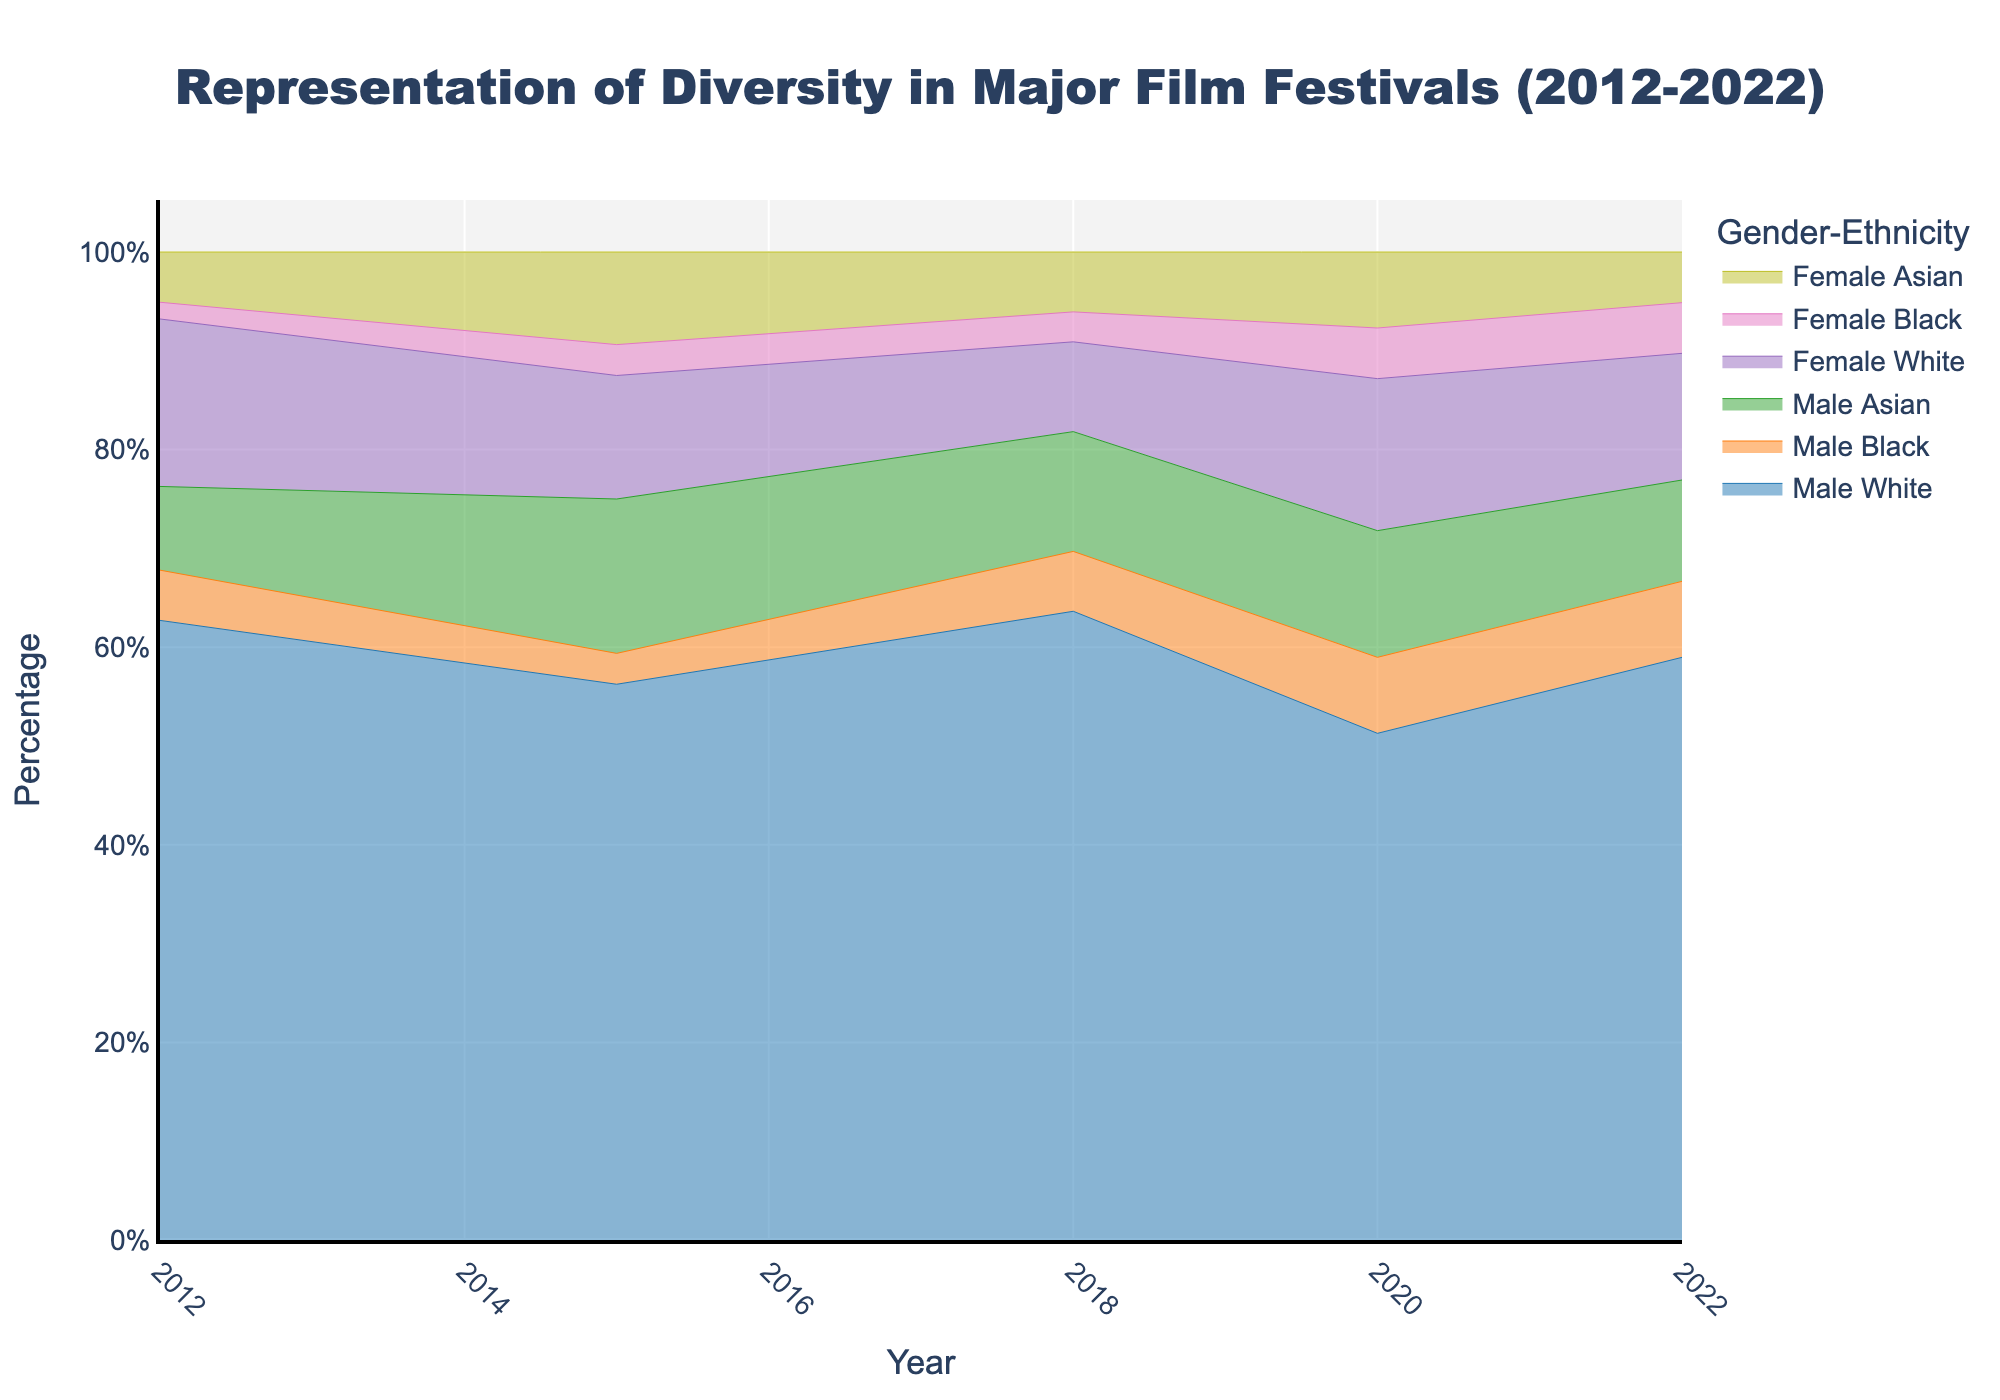What's the title of the figure? The title is usually prominently displayed at the top of the figure. Here, the title of the figure is given as "Representation of Diversity in Major Film Festivals (2012-2022)."
Answer: Representation of Diversity in Major Film Festivals (2012-2022) Which axis represents the year? In most graphs, the x-axis typically represents time when it's involved. In this figure, the x-axis displays the years from 2012 to 2022.
Answer: x-axis What color is used to represent male white directors? The figure uses different colors to represent different categories. The line representing male white directors is colored in blue.
Answer: Blue How does the percentage of male white directors change from 2012 to 2022? To find out how the percentage changes, look at the blue line representing male white directors. Notice the trend from 2012 to 2022. The percentage starts relatively high in 2012, fluctuates over the years but remains one of the higher percentages throughout the period, ending similarly high in 2022.
Answer: High at start and remains high What is the overall trend in the representation of female black directors from 2012 to 2022? Observe the line for female black directors, indicated by a specific color. From 2012 to 2022, the percentage shows a slight increase over time, indicating a gradual improvement in their representation in major film festivals.
Answer: Gradual increase Which ethnic group of male directors shows the most significant growth over the decade? Compare the lines for male directors of different ethnicities (white, black, Asian). The group with the steepest upward trajectory indicates the most growth. Male Asian directors show a noticeable increase over the decade.
Answer: Male Asian directors How do male and female white directors' representations compare in 2018? Look at the specific points in 2018 for both the blue (male white) and purple (female white) lines. Compare their percentages directly at the year 2018. Male white directors have a higher representation compared to female white directors in 2018.
Answer: Male higher than female What year shows the highest percentage of female Asian directors? To find this, trace the line representing female Asian directors (yellow). Identify the year where the line reaches its peak to find the highest percentage year.
Answer: 2015 How does the combined representation of black directors (both genders) in 2020 compare to that in 2012? Add up the percentages for both male and female black directors for the years 2012 and 2020. In 2020, the combined total for black directors (male and female) is higher compared to 2012.
Answer: Higher in 2020 